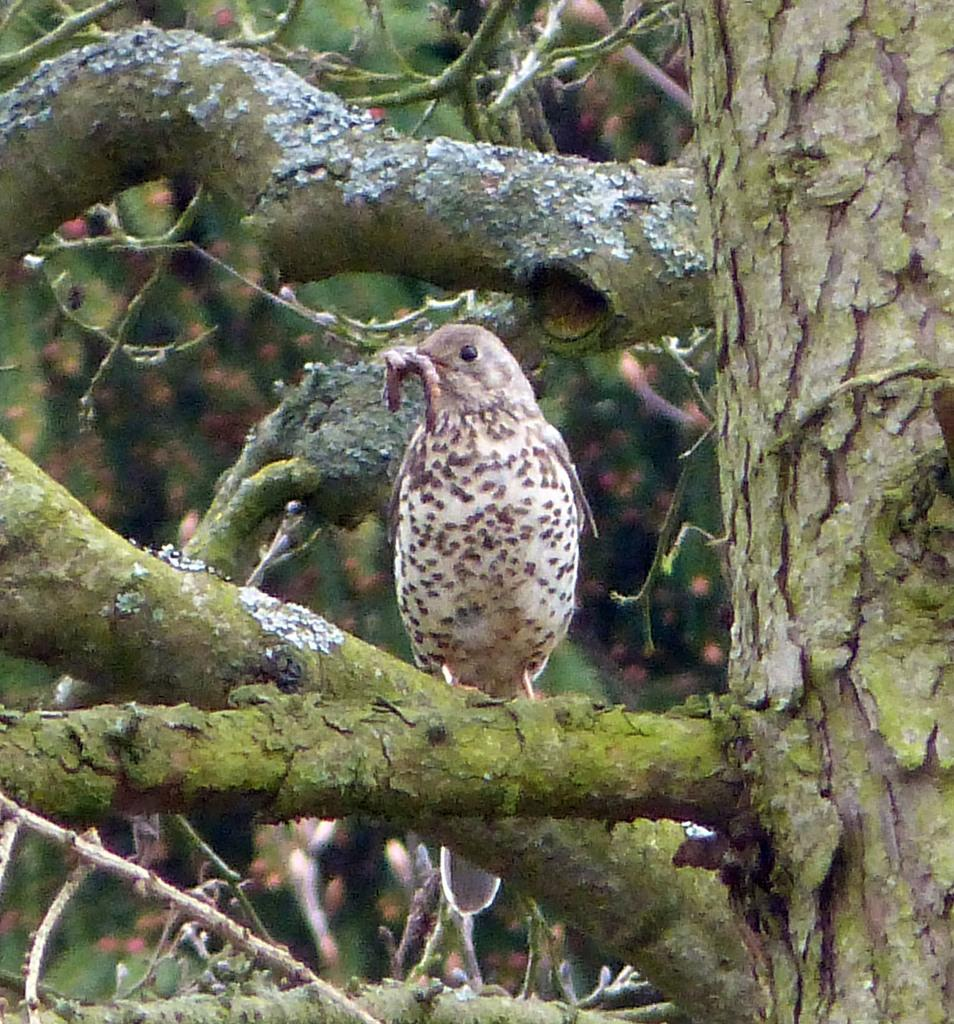What is the main subject of the image? The main subject of the image is a tree trunk. What else can be seen in the image besides the tree trunk? There are branches and a bird on one of the branches in the image. How clear is the image in the background? The image is slightly blurry in the background. How many bikes are parked near the tree in the image? There are no bikes present in the image. What items are on the list that can be seen in the image? There is no list present in the image. 